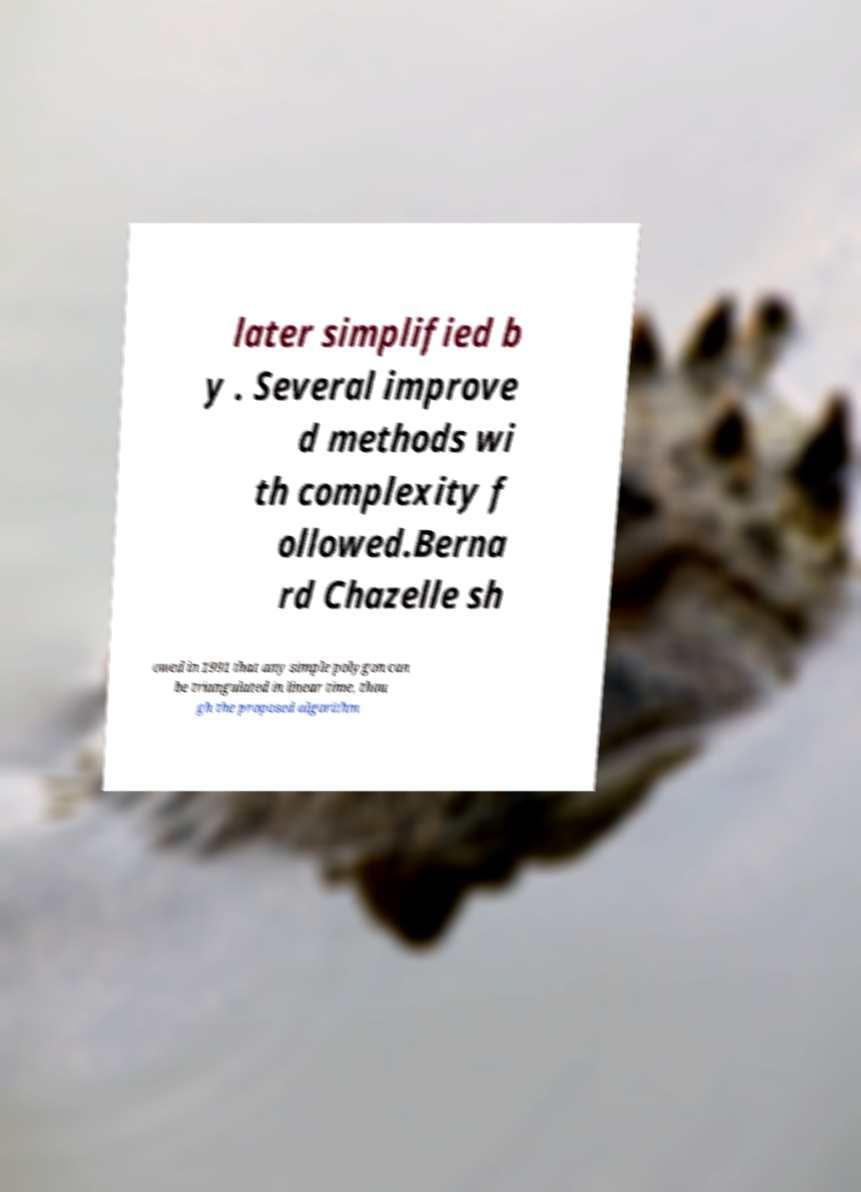Can you accurately transcribe the text from the provided image for me? later simplified b y . Several improve d methods wi th complexity f ollowed.Berna rd Chazelle sh owed in 1991 that any simple polygon can be triangulated in linear time, thou gh the proposed algorithm 